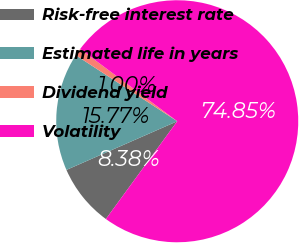Convert chart to OTSL. <chart><loc_0><loc_0><loc_500><loc_500><pie_chart><fcel>Risk-free interest rate<fcel>Estimated life in years<fcel>Dividend yield<fcel>Volatility<nl><fcel>8.38%<fcel>15.77%<fcel>1.0%<fcel>74.85%<nl></chart> 